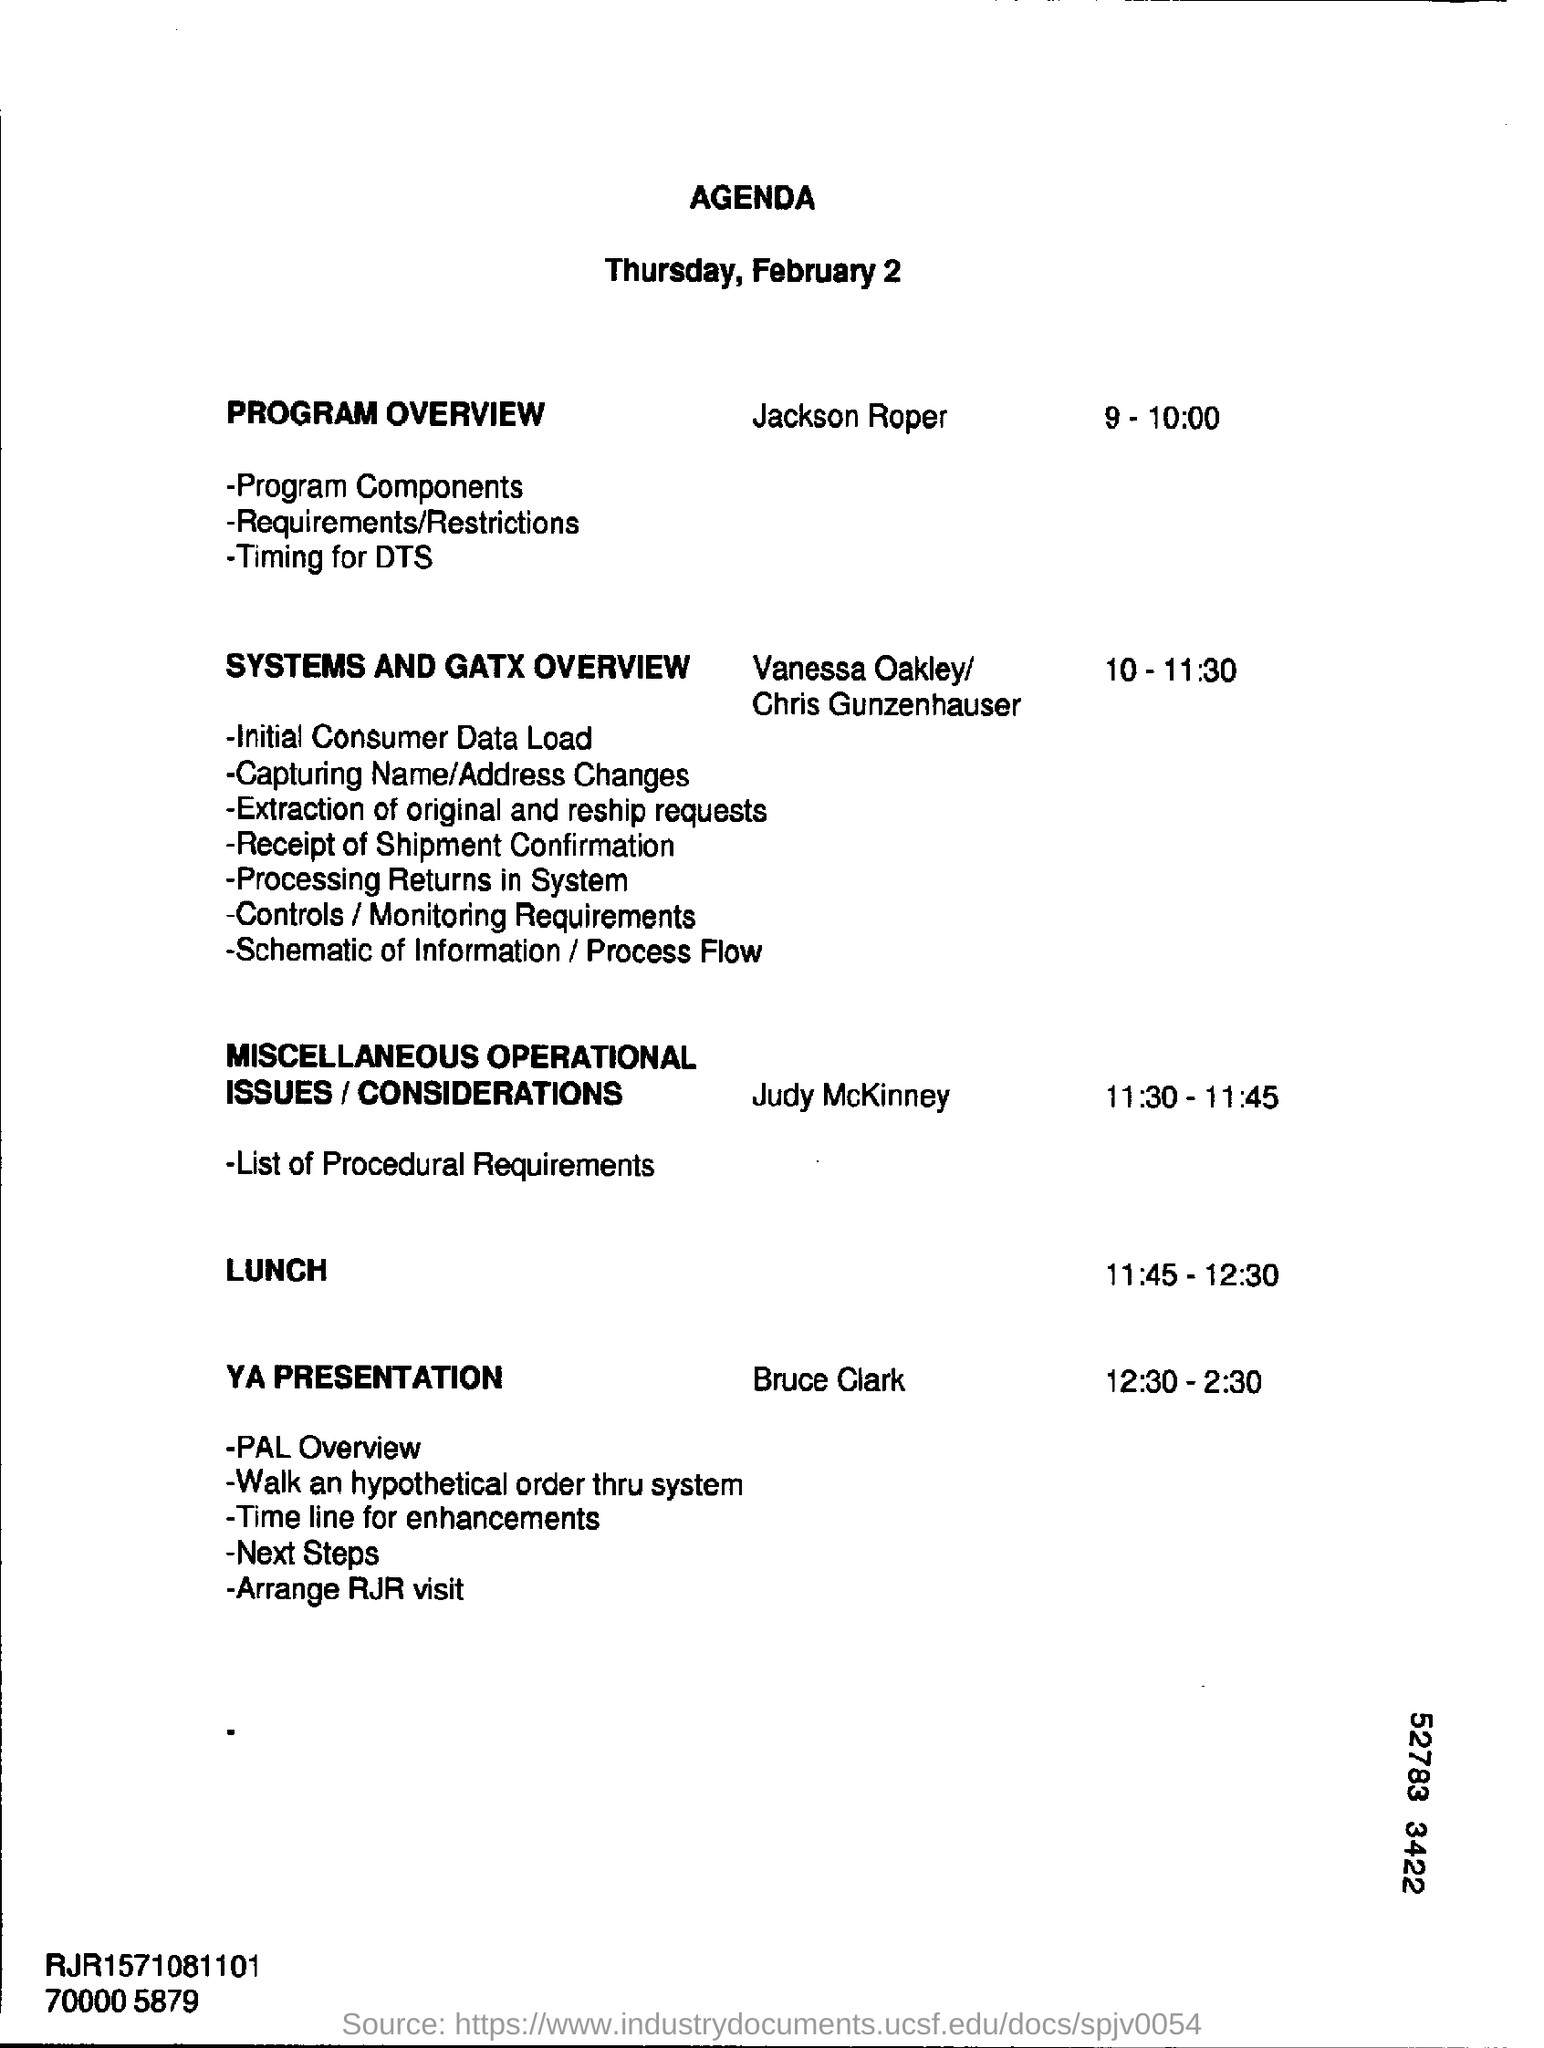List a handful of essential elements in this visual. The time slot of 11.30-11.45 has been designated for miscellaneous operational issues. The Program Overview is discussed by Jackson Roper. What is time mentioned for "Systems and gatx overview"? It is from 10:00-11:30. What is time mentioned for YA Presentation? The hours are 12:30 to 2:30. The session will be spoken and handled by Bruce Clark, who is referred to as YA Presentation. 